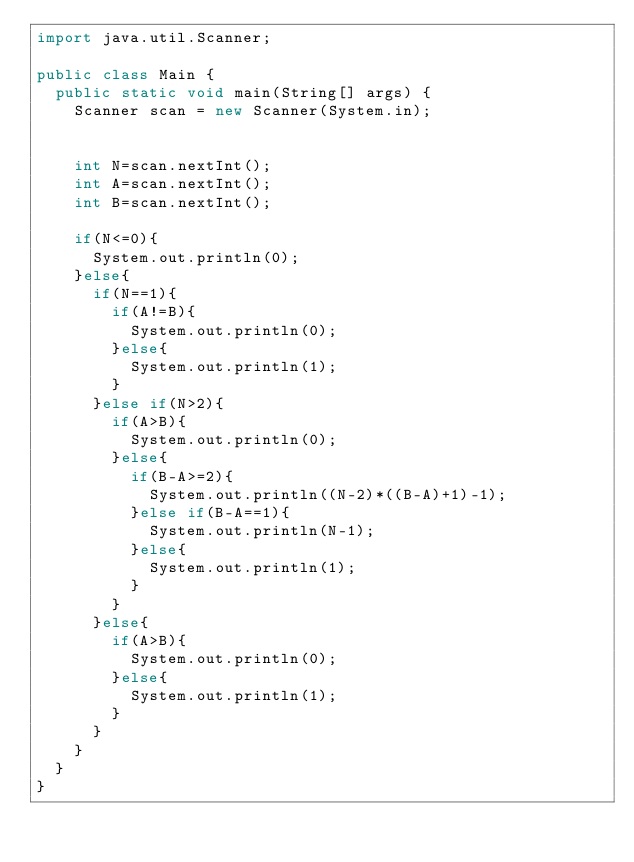<code> <loc_0><loc_0><loc_500><loc_500><_Java_>import java.util.Scanner;

public class Main {
	public static void main(String[] args) {
		Scanner scan = new Scanner(System.in);

		
		int N=scan.nextInt();
		int A=scan.nextInt();
		int B=scan.nextInt();
		
		if(N<=0){
			System.out.println(0);
		}else{
			if(N==1){
				if(A!=B){
					System.out.println(0);
				}else{
					System.out.println(1);
				}
			}else if(N>2){
				if(A>B){
					System.out.println(0);
				}else{
					if(B-A>=2){
						System.out.println((N-2)*((B-A)+1)-1);
					}else if(B-A==1){
						System.out.println(N-1);
					}else{
						System.out.println(1);
					}
				}
			}else{
				if(A>B){
					System.out.println(0);
				}else{
					System.out.println(1);
				}
			}
		}
	}
}</code> 